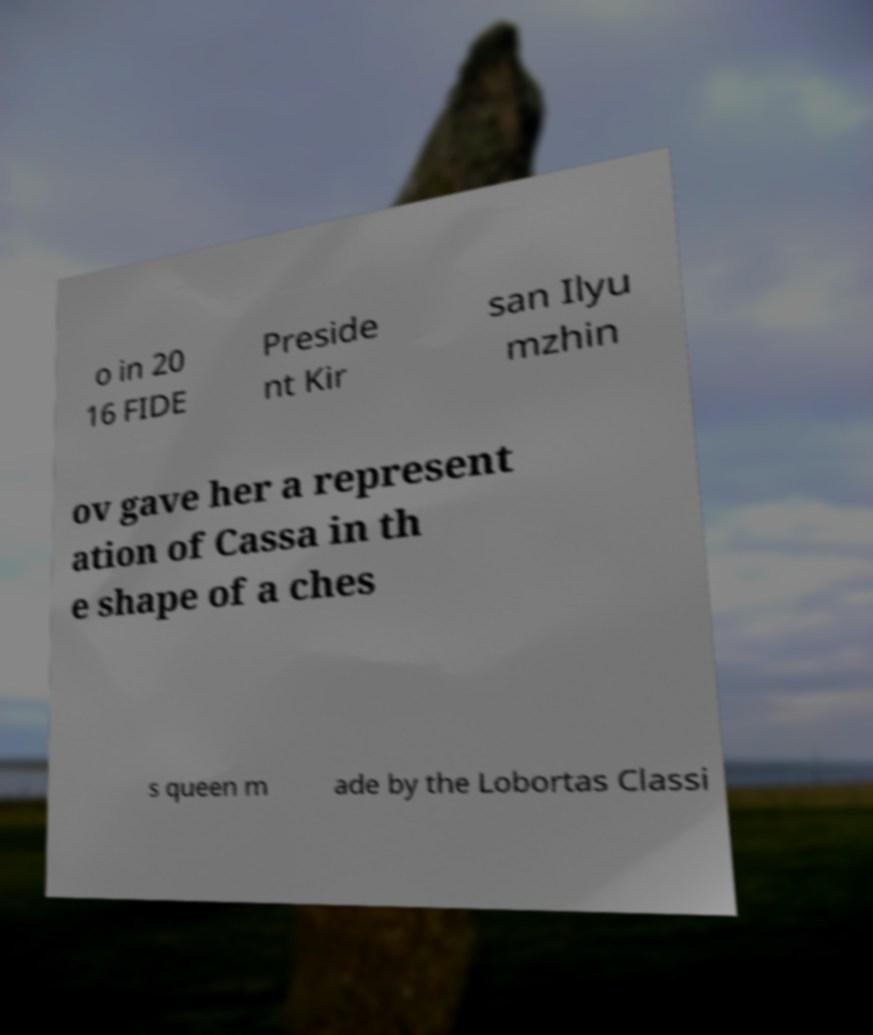What messages or text are displayed in this image? I need them in a readable, typed format. o in 20 16 FIDE Preside nt Kir san Ilyu mzhin ov gave her a represent ation of Cassa in th e shape of a ches s queen m ade by the Lobortas Classi 